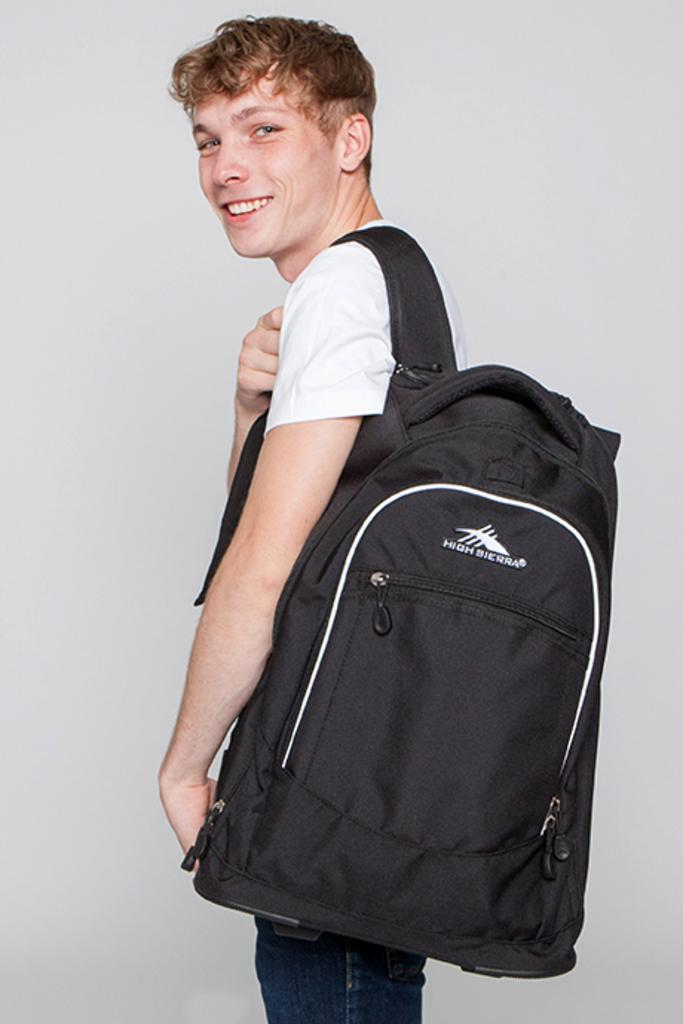Who is the main subject in the picture? There is a boy in the picture. What is the boy doing in the image? The boy is standing in the picture. What is the boy's facial expression in the image? The boy is smiling in the image. What is the boy wearing in the picture? The boy is wearing a black bag in the image. What type of juice is the boy holding in the image? There is no juice present in the image; the boy is wearing a black bag. What kind of wind can be seen blowing through the cemetery in the image? There is no cemetery present in the image, and therefore no wind can be observed. 